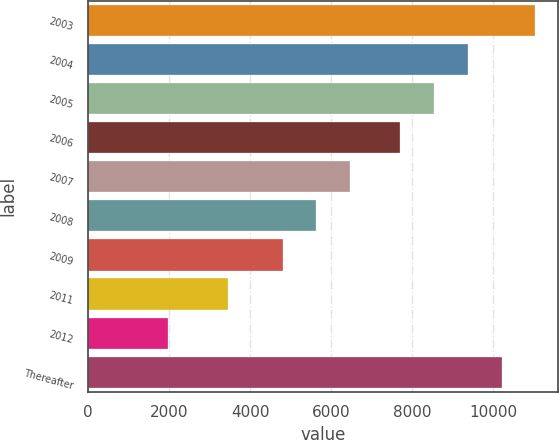<chart> <loc_0><loc_0><loc_500><loc_500><bar_chart><fcel>2003<fcel>2004<fcel>2005<fcel>2006<fcel>2007<fcel>2008<fcel>2009<fcel>2011<fcel>2012<fcel>Thereafter<nl><fcel>11034.8<fcel>9368.4<fcel>8535.2<fcel>7702<fcel>6468.4<fcel>5635.2<fcel>4802<fcel>3462<fcel>1977<fcel>10201.6<nl></chart> 